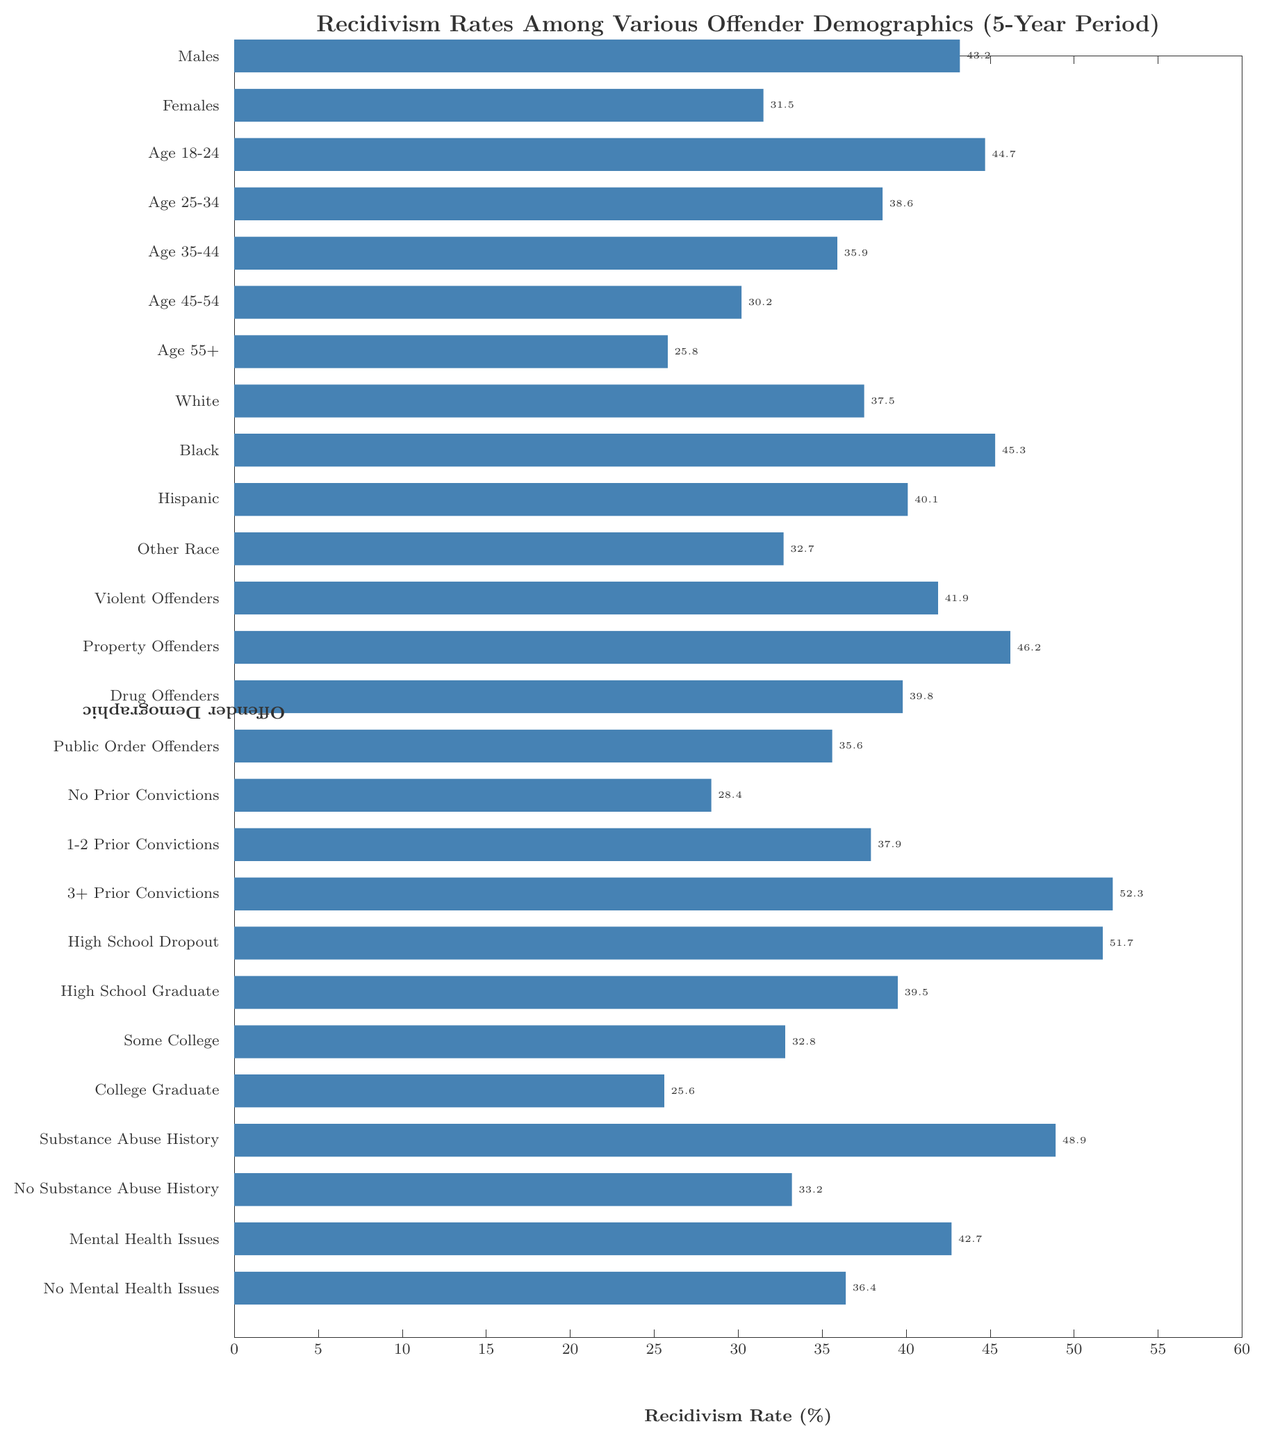What's the highest recidivism rate among all offender demographics? Observe the bar corresponding to the highest value in the plot. The "3+ Prior Convictions" category has the highest bar, indicating a recidivism rate of 52.3%.
Answer: 52.3% Which gender has a higher recidivism rate, males or females? Compare the bars for "Males" and "Females". The bar for "Males" is higher, indicating a recidivism rate of 43.2% as opposed to 31.5% for "Females".
Answer: Males What's the difference in recidivism rates between offenders with a history of substance abuse and those without? Identify the bars for "Substance Abuse History" and "No Substance Abuse History". The recidivism rates are 48.9% and 33.2% respectively. The difference is 48.9 - 33.2 = 15.7%.
Answer: 15.7% What's the average recidivism rate for age groups 25-34, 35-44, and 45-54? Identify the bars for "Age 25-34" (38.6%), "Age 35-44" (35.9%), and "Age 45-54" (30.2%). Compute the average: (38.6 + 35.9 + 30.2) / 3 = 34.9%.
Answer: 34.9% Which group has a lower recidivism rate: those with mental health issues or those with no mental health issues? Compare the bars for "Mental Health Issues" and "No Mental Health Issues". The recidivism rates are 42.7% and 36.4% respectively, so those with no mental health issues have a lower rate.
Answer: No Mental Health Issues What is the combined recidivism rate for Property Offenders and Violent Offenders? Identify the bars for "Property Offenders" (46.2%) and "Violent Offenders" (41.9%). Add the rates together to get 46.2 + 41.9 = 88.1%.
Answer: 88.1% Which has a higher recidivism rate: Drug Offenders or Public Order Offenders? Compare the bars for "Drug Offenders" and "Public Order Offenders". "Drug Offenders" have a recidivism rate of 39.8%, while "Public Order Offenders" have 35.6%. Therefore, "Drug Offenders" have a higher rate.
Answer: Drug Offenders What's the recidivism rate difference between offenders aged 18-24 and those aged 55+? Examine the bars for "Age 18-24" (44.7%) and "Age 55+" (25.8%). The difference is 44.7 - 25.8 = 18.9%.
Answer: 18.9% What is the median recidivism rate among all the offender demographics listed? List the rates in ascending order: 25.6, 25.8, 28.4, 30.2, 31.5, 32.7, 32.8, 33.2, 35.6, 35.9, 36.4, 37.5, 37.9, 38.6, 39.5, 39.8, 40.1, 41.9, 42.7, 43.2, 44.7, 45.3, 46.2, 48.9, 51.7, 52.3. With 26 data points, the median is the average of the 13th and 14th values: (37.9 + 38.6) / 2 = 38.25%.
Answer: 38.25% How much higher is the recidivism rate for high school dropouts compared to college graduates? Identify the bars for "High School Dropout" (51.7%) and "College Graduate" (25.6%). Subtract to find the difference: 51.7 - 25.6 = 26.1%.
Answer: 26.1% 